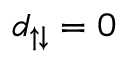<formula> <loc_0><loc_0><loc_500><loc_500>d _ { \uparrow \downarrow } = 0</formula> 